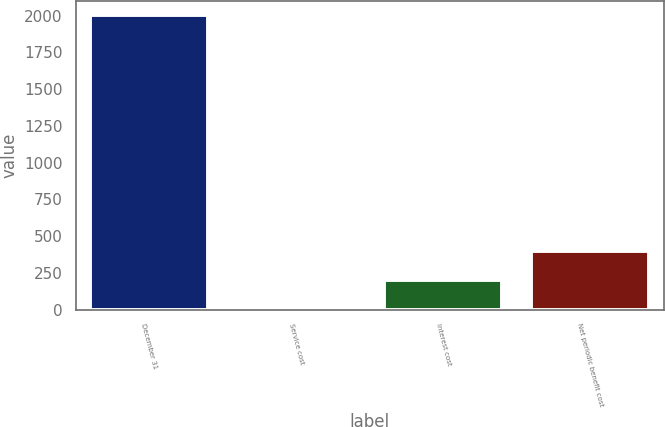Convert chart. <chart><loc_0><loc_0><loc_500><loc_500><bar_chart><fcel>December 31<fcel>Service cost<fcel>Interest cost<fcel>Net periodic benefit cost<nl><fcel>2001<fcel>0.5<fcel>200.55<fcel>400.6<nl></chart> 